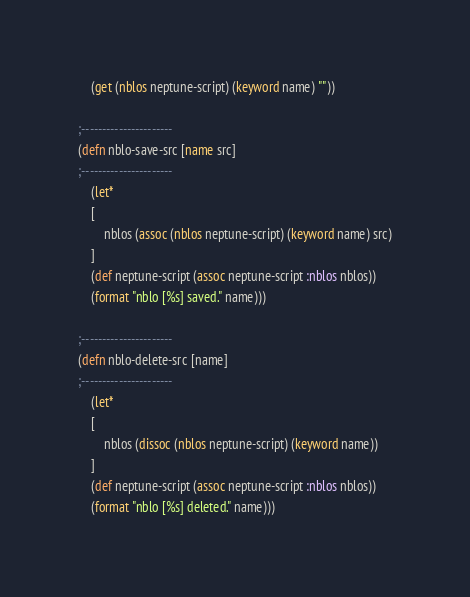<code> <loc_0><loc_0><loc_500><loc_500><_Clojure_>	(get (nblos neptune-script) (keyword name) ""))

;----------------------
(defn nblo-save-src [name src]
;----------------------
	(let*
	[
		nblos (assoc (nblos neptune-script) (keyword name) src)
	]
	(def neptune-script (assoc neptune-script :nblos nblos))
	(format "nblo [%s] saved." name)))

;----------------------
(defn nblo-delete-src [name]
;----------------------
	(let*
	[
		nblos (dissoc (nblos neptune-script) (keyword name))
	]
	(def neptune-script (assoc neptune-script :nblos nblos))
	(format "nblo [%s] deleted." name)))

</code> 